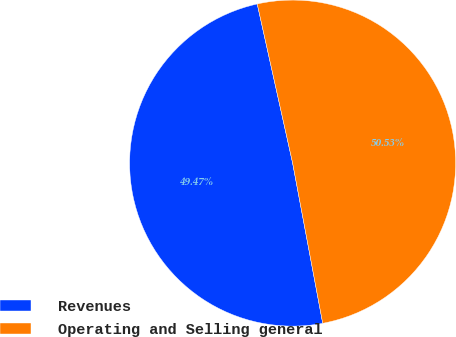Convert chart. <chart><loc_0><loc_0><loc_500><loc_500><pie_chart><fcel>Revenues<fcel>Operating and Selling general<nl><fcel>49.47%<fcel>50.53%<nl></chart> 